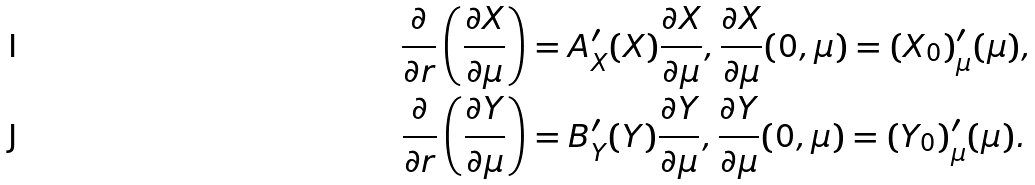<formula> <loc_0><loc_0><loc_500><loc_500>\frac { \partial } { \partial r } \left ( \frac { \partial X } { \partial \mu } \right ) & = A ^ { \prime } _ { X } ( X ) \frac { \partial X } { \partial \mu } , \frac { \partial X } { \partial \mu } ( 0 , \mu ) = ( X _ { 0 } ) ^ { \prime } _ { \mu } ( \mu ) , \\ \frac { \partial } { \partial r } \left ( \frac { \partial Y } { \partial \mu } \right ) & = B ^ { \prime } _ { Y } ( Y ) \frac { \partial Y } { \partial \mu } , \frac { \partial Y } { \partial \mu } ( 0 , \mu ) = ( Y _ { 0 } ) ^ { \prime } _ { \mu } ( \mu ) .</formula> 